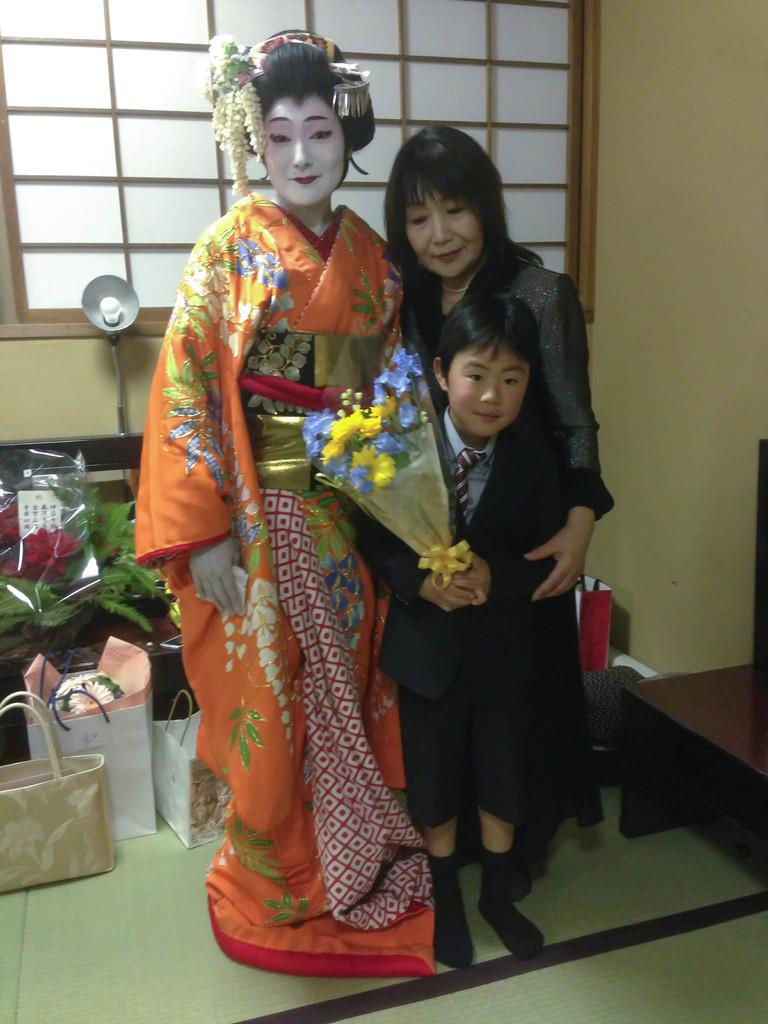How many people are in the image? There are three people in the image. What is the facial expression of the people in the image? The people are smiling. Where are the people standing in the image? The people are standing on the floor. What can be seen on the table in the image? There is a flower bouquet and bags on the table. What type of vegetation is present in the image? Leaves are present in the image. What is the source of light in the image? There is a lamp in the image. What architectural feature can be seen in the image? There is a window in the image. What is the background of the image made of? There is a wall in the image. What is the woman wearing in the image? A woman is wearing a costume. How quickly does the camp move in the image? There is no camp present in the image. What is the height of the low vegetation in the image? There is no low vegetation present in the image. 